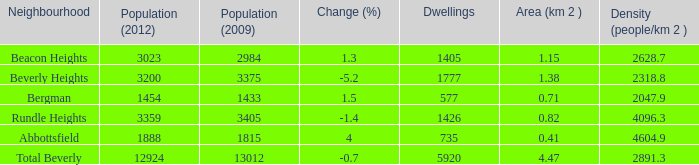What is the density of an area that is 1.38km and has a population more than 12924? 0.0. 